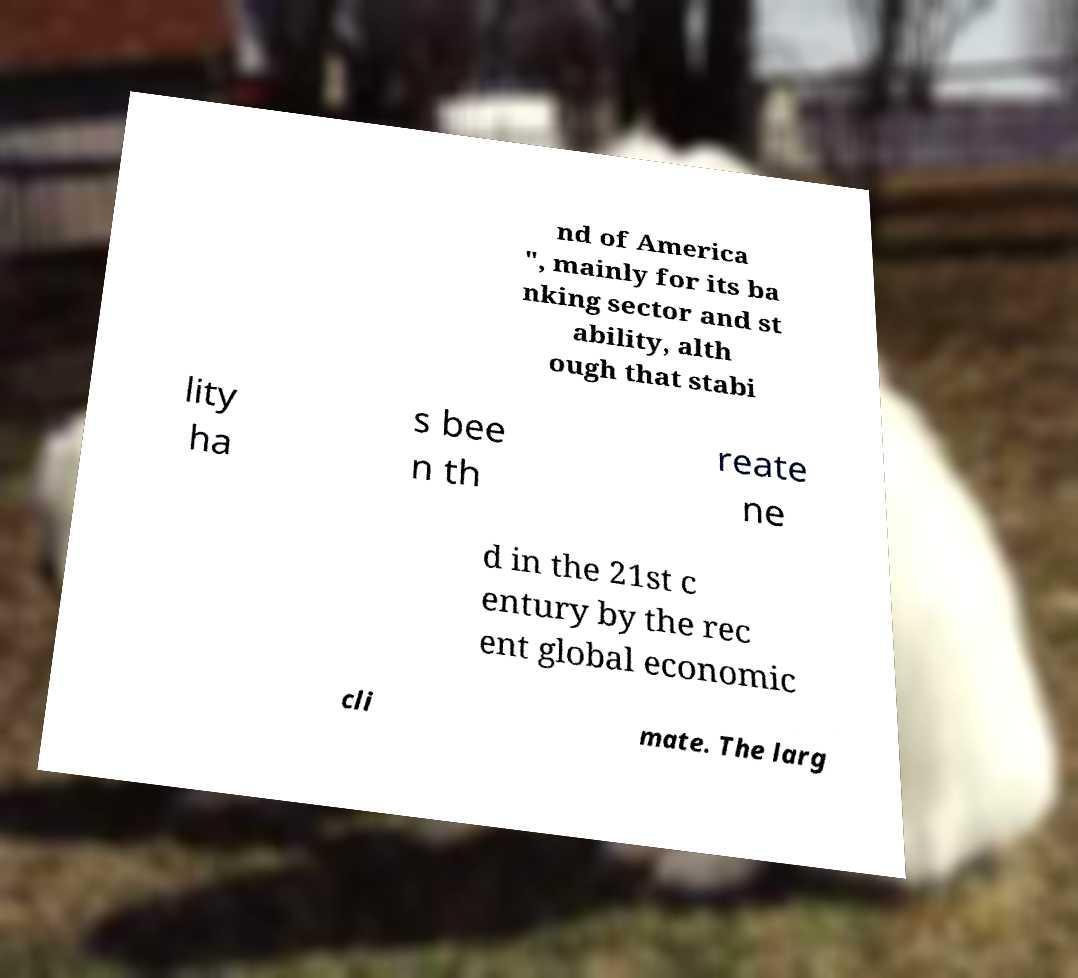Please read and relay the text visible in this image. What does it say? nd of America ", mainly for its ba nking sector and st ability, alth ough that stabi lity ha s bee n th reate ne d in the 21st c entury by the rec ent global economic cli mate. The larg 